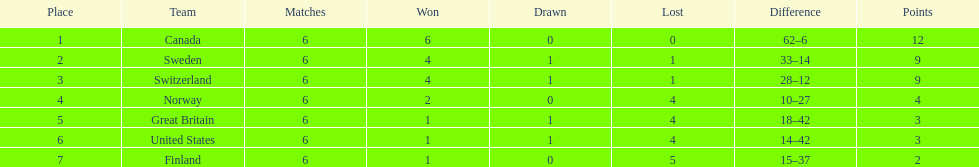What is the number of teams that won just a single match? 3. 